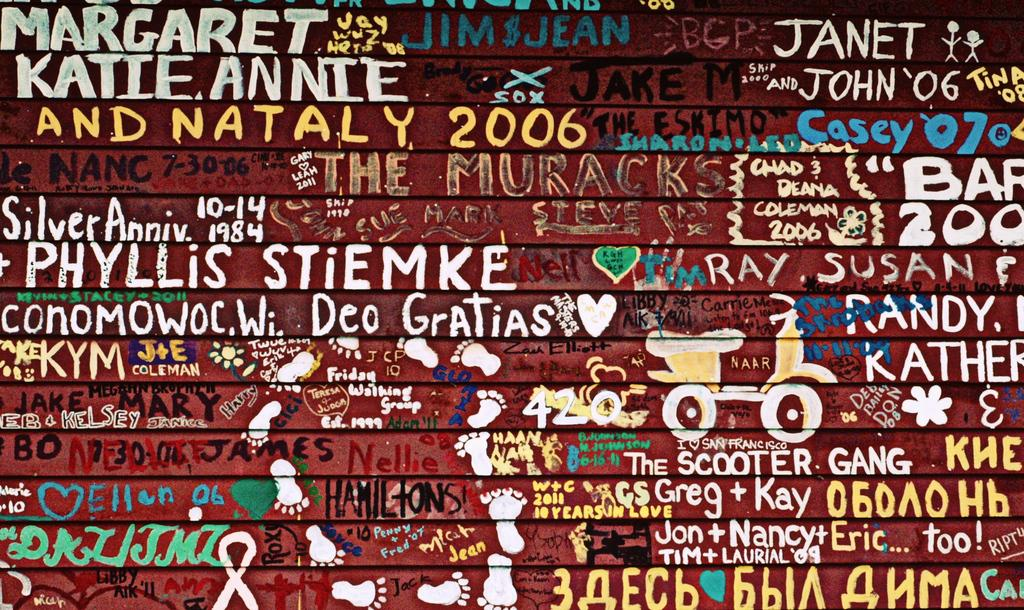<image>
Relay a brief, clear account of the picture shown. a collage poster with names like ray, susan 